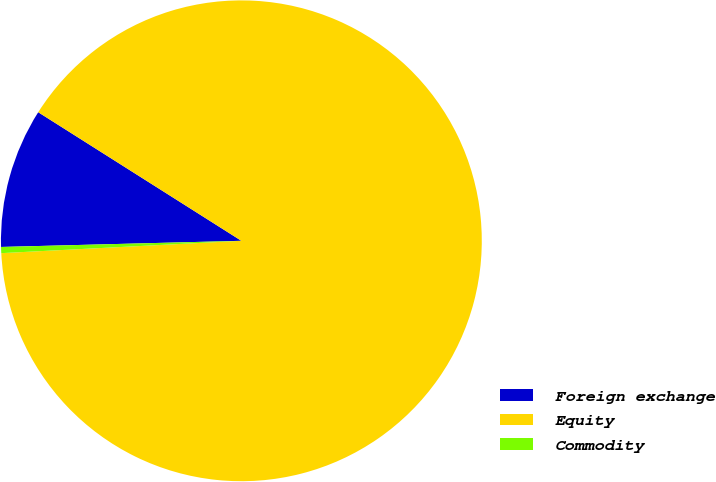Convert chart. <chart><loc_0><loc_0><loc_500><loc_500><pie_chart><fcel>Foreign exchange<fcel>Equity<fcel>Commodity<nl><fcel>9.39%<fcel>90.21%<fcel>0.41%<nl></chart> 